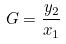<formula> <loc_0><loc_0><loc_500><loc_500>G = \frac { y _ { 2 } } { x _ { 1 } }</formula> 